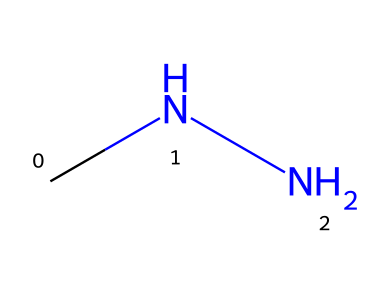What is the molecular formula of monomethylhydrazine? The SMILES representation "CNN" indicates that the molecular formula contains two carbon (C) atoms and four nitrogen (N) atoms, as each atom type is identified in the structure. Therefore, the complete formula is C2H8N2.
Answer: C2H8N2 How many hydrogen atoms are present in the compound? Analyzing the SMILES representation, "CNN," shows that both nitrogen atoms are bonded to one carbon atom and have hydrogen atoms attached, totaling eight hydrogen atoms in the structure.
Answer: Eight What type of chemical bond is formed between carbon and nitrogen in this compound? In the SMILES "CNN," carbon and nitrogen atoms are bonded with covalent bonds, which are formed by the sharing of electron pairs. Since both carbon and nitrogen can share electrons, covalent bonding is characteristic of this compound.
Answer: Covalent Is monomethylhydrazine a polar or nonpolar molecule? By assessing the SMILES structure, the presence of nitrogen and the arrangement of hydrogen and carbon suggest an uneven electron distribution, leading to a dipole moment, which indicates that monomethylhydrazine is a polar molecule.
Answer: Polar What is a common use of monomethylhydrazine? Monomethylhydrazine is often used as a rocket propellant; its chemical structure and properties make it suitable for applications in propulsion systems, such as in spacecraft.
Answer: Rocket propellant Does monomethylhydrazine pose environmental risks? Yes, due to its toxicity and potential for contamination, monomethylhydrazine is considered an environmental contaminant, especially in areas where it is used in rocket fuel.
Answer: Yes 